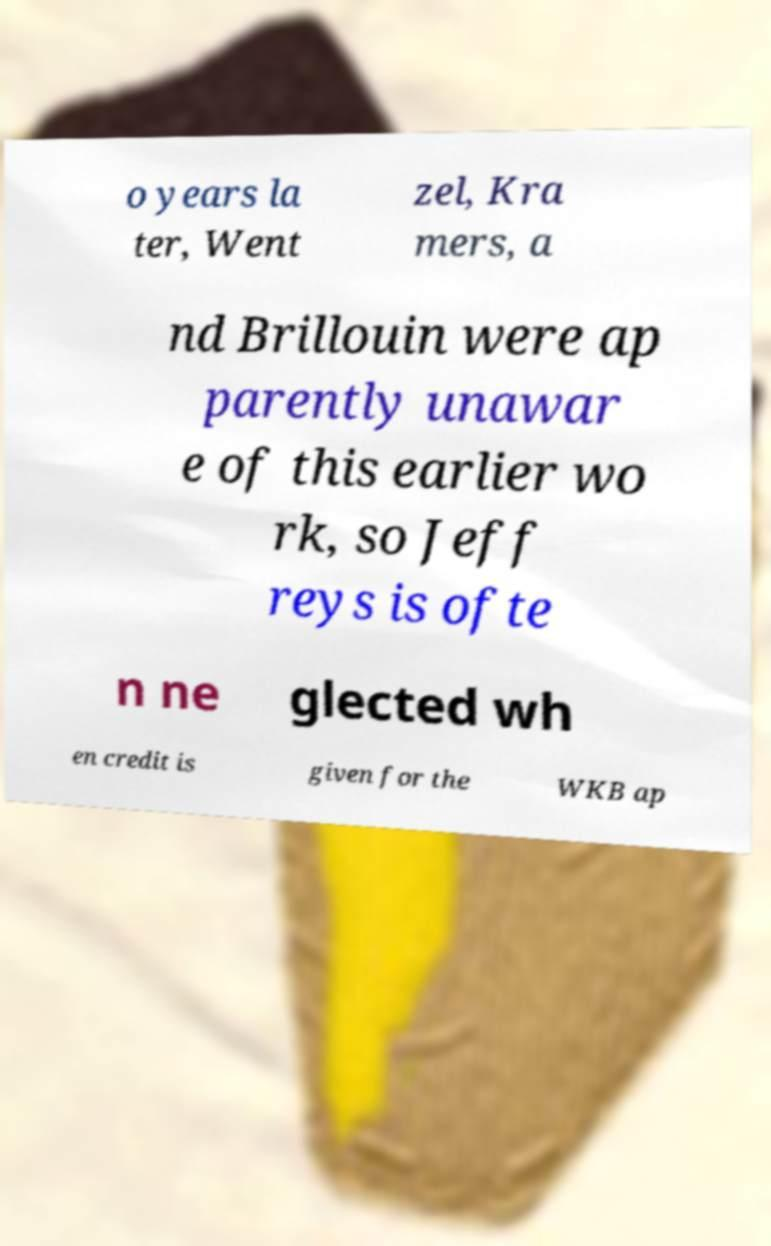Can you accurately transcribe the text from the provided image for me? o years la ter, Went zel, Kra mers, a nd Brillouin were ap parently unawar e of this earlier wo rk, so Jeff reys is ofte n ne glected wh en credit is given for the WKB ap 